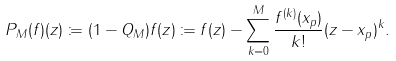<formula> <loc_0><loc_0><loc_500><loc_500>P _ { M } ( f ) ( z ) \coloneqq ( 1 - Q _ { M } ) f ( z ) \coloneqq f ( z ) - \sum _ { k = 0 } ^ { M } \frac { f ^ { ( k ) } ( x _ { p } ) } { k ! } ( z - x _ { p } ) ^ { k } .</formula> 